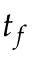<formula> <loc_0><loc_0><loc_500><loc_500>t _ { f }</formula> 